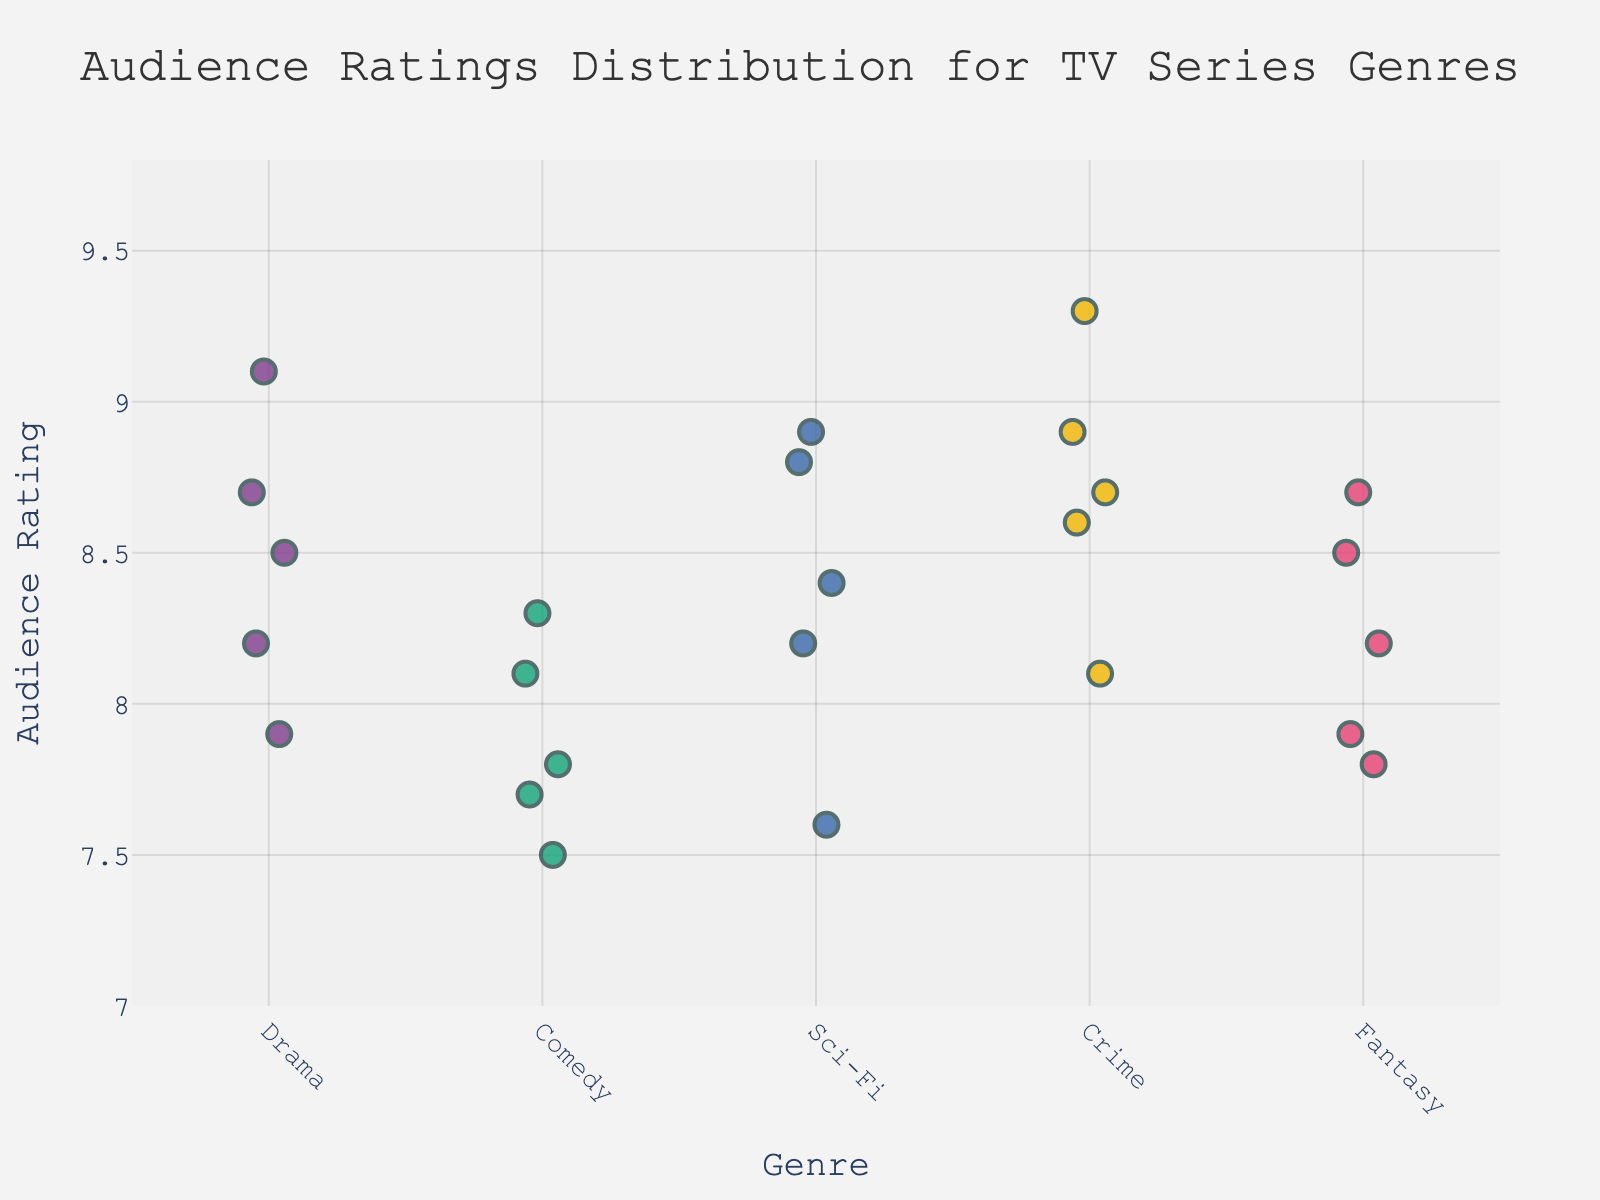Which genre has the highest audience rating? To determine the genre with the highest audience rating, look at the highest data point on the y-axis. The highest rating belongs to the Crime genre with a rating of 9.3.
Answer: Crime What is the range of audience ratings for the Drama genre? The range is the difference between the highest and lowest ratings within the Drama genre. The highest rating is 9.1 and the lowest is 7.9. Therefore, the range is 9.1 - 7.9.
Answer: 1.2 How many data points are there for each genre? Count the number of points (dots) for each genre on the x-axis. Each genre has 5 data points.
Answer: 5 Which genre has the lowest average rating? To find the genre with the lowest average rating, compute the average rating for each genre then compare them. The averages are: Drama (8.48), Comedy (7.88), Sci-Fi (8.38), Crime (8.72), Fantasy (8.22). Therefore, Comedy has the lowest average rating.
Answer: Comedy What is the median audience rating for Sci-Fi? To determine the median, sort the Sci-Fi ratings (7.6, 8.2, 8.4, 8.8, 8.9) and identify the middle value, which is 8.4.
Answer: 8.4 Which genres have at least one rating above 9? Look at the ratings for each genre and check for ratings above 9. Only Drama and Crime have ratings above 9 (Drama with 9.1 and Crime with 9.3).
Answer: Drama, Crime What is the difference between the highest rating in the Comedy genre and the lowest rating in the Sci-Fi genre? The highest rating in the Comedy genre is 8.3, and the lowest in the Sci-Fi genre is 7.6. The difference is 8.3 - 7.6.
Answer: 0.7 Is there any genre where all ratings are above 8? Check each genre and see if all data points have ratings above 8. Only Crime has all ratings above 8.
Answer: Crime How consistent are the ratings in the Fantasy genre compared to the Comedy genre? Consistency can be assessed by the spread of ratings. Fantasy ratings range from 7.8 to 8.7 (range 0.9), while Comedy ratings range from 7.5 to 8.3 (range 0.8), indicating similar consistency.
Answer: Similar consistency Which genre shows the most variability in ratings? The variability can be assessed by the range of the ratings. Sci-Fi ratings range from 7.6 to 8.9 (range 1.3), which is the largest among all genres.
Answer: Sci-Fi 